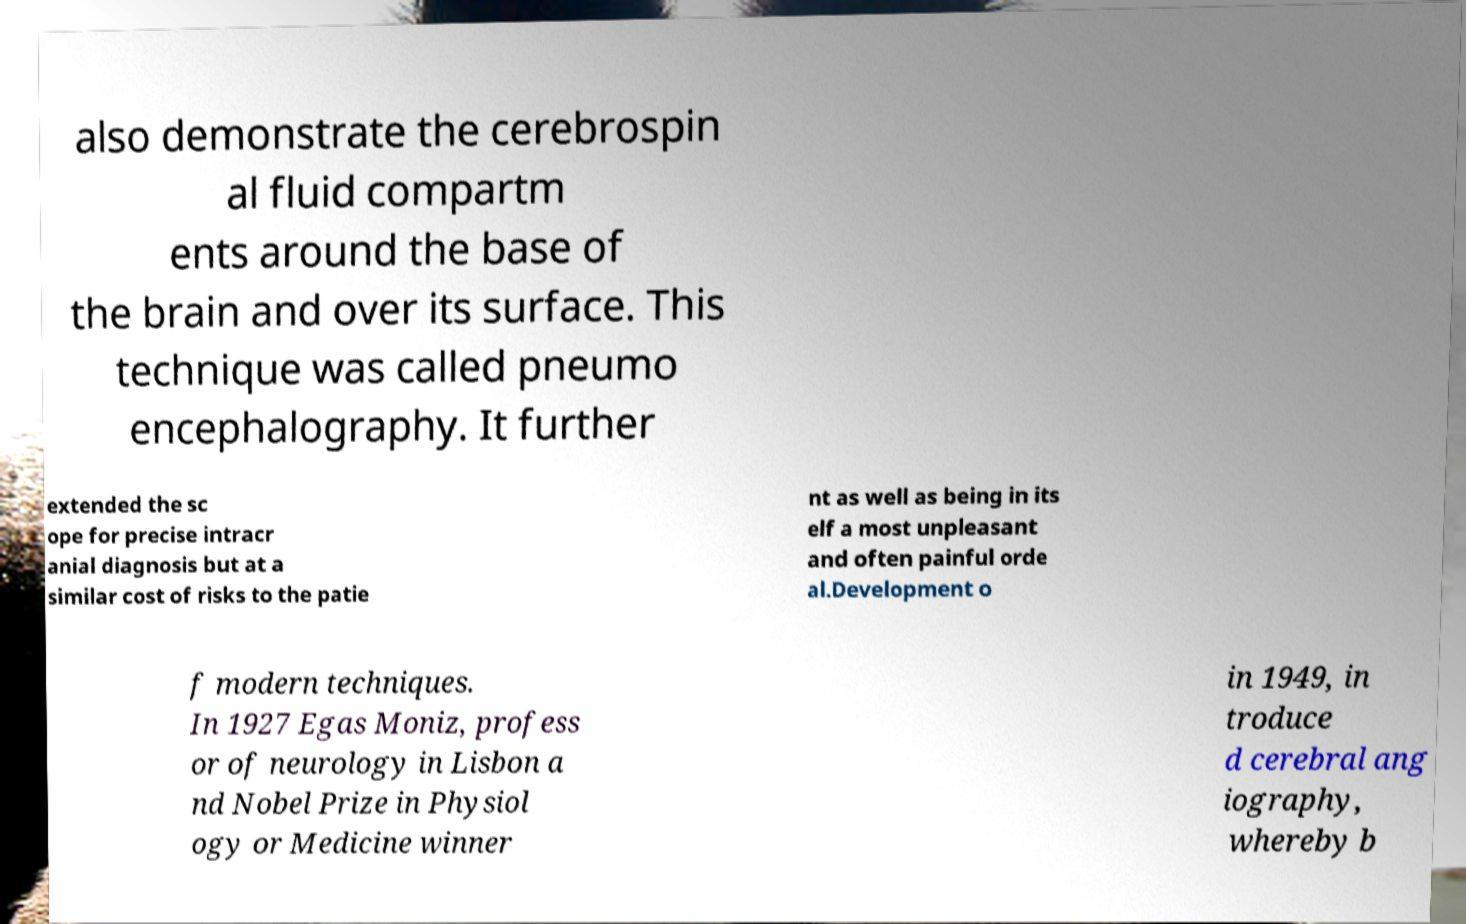For documentation purposes, I need the text within this image transcribed. Could you provide that? also demonstrate the cerebrospin al fluid compartm ents around the base of the brain and over its surface. This technique was called pneumo encephalography. It further extended the sc ope for precise intracr anial diagnosis but at a similar cost of risks to the patie nt as well as being in its elf a most unpleasant and often painful orde al.Development o f modern techniques. In 1927 Egas Moniz, profess or of neurology in Lisbon a nd Nobel Prize in Physiol ogy or Medicine winner in 1949, in troduce d cerebral ang iography, whereby b 